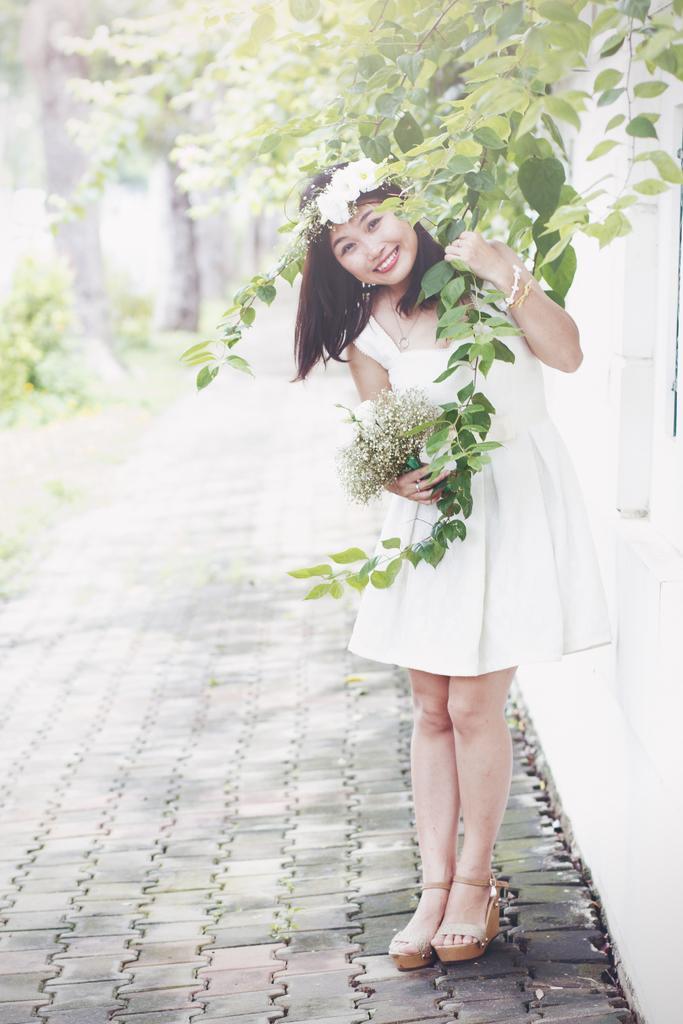How would you summarize this image in a sentence or two? In this picture there is a woman standing and smiling and holding the flowers. At the back there are trees. On the right side of the image there is a wall and there is a tree. At the bottom there is a pavement and there is grass. 